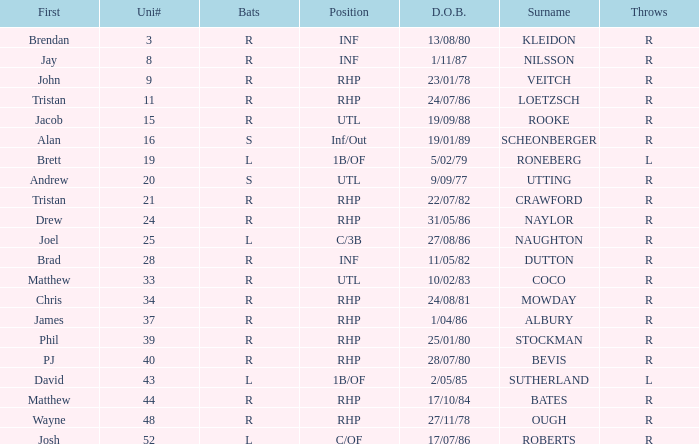Which First has a Uni # larger than 34, and Throws of r, and a Position of rhp, and a Surname of stockman? Phil. 